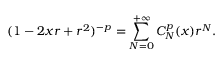Convert formula to latex. <formula><loc_0><loc_0><loc_500><loc_500>( 1 - 2 x r + r ^ { 2 } ) ^ { - p } = \sum _ { N = 0 } ^ { + \infty } C _ { N } ^ { p } ( x ) r ^ { N } .</formula> 